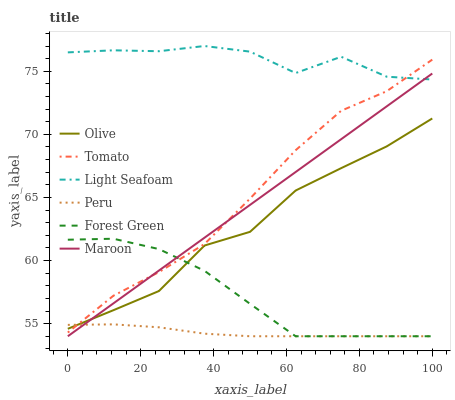Does Maroon have the minimum area under the curve?
Answer yes or no. No. Does Maroon have the maximum area under the curve?
Answer yes or no. No. Is Forest Green the smoothest?
Answer yes or no. No. Is Forest Green the roughest?
Answer yes or no. No. Does Olive have the lowest value?
Answer yes or no. No. Does Maroon have the highest value?
Answer yes or no. No. Is Olive less than Light Seafoam?
Answer yes or no. Yes. Is Light Seafoam greater than Olive?
Answer yes or no. Yes. Does Olive intersect Light Seafoam?
Answer yes or no. No. 